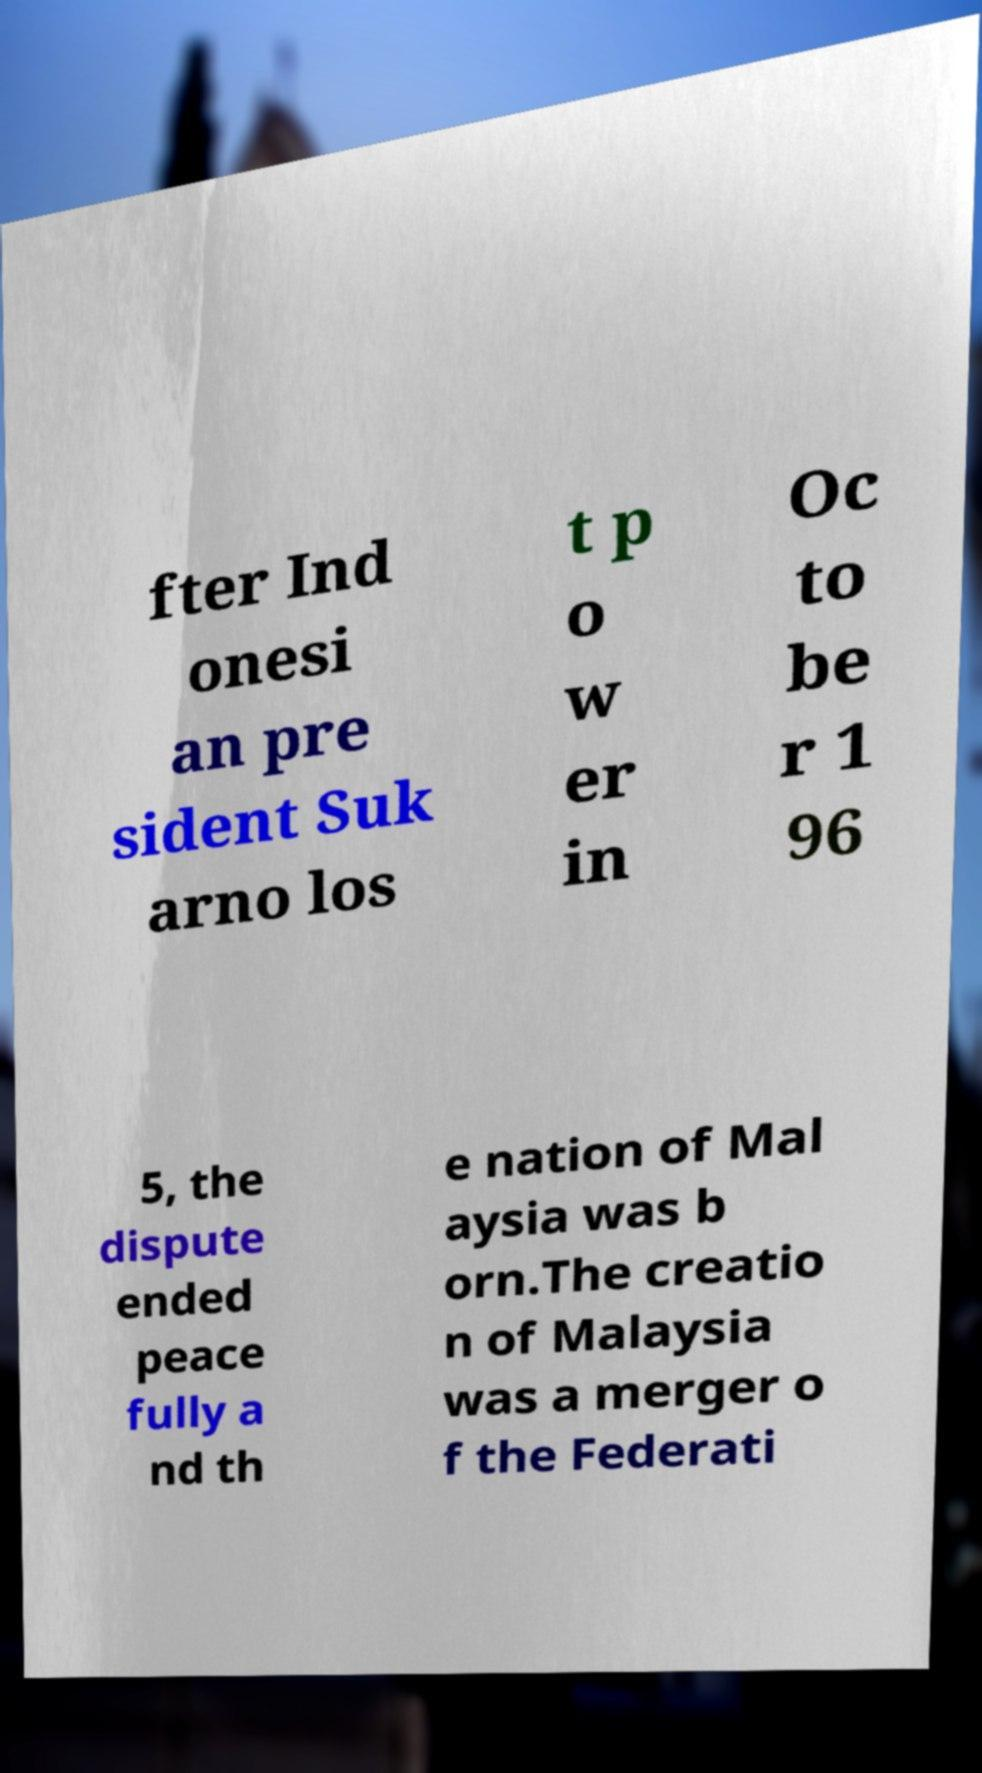There's text embedded in this image that I need extracted. Can you transcribe it verbatim? fter Ind onesi an pre sident Suk arno los t p o w er in Oc to be r 1 96 5, the dispute ended peace fully a nd th e nation of Mal aysia was b orn.The creatio n of Malaysia was a merger o f the Federati 